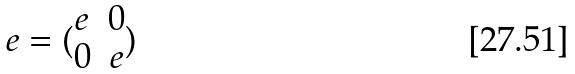<formula> <loc_0><loc_0><loc_500><loc_500>e = ( \begin{matrix} e & 0 \\ 0 & e \end{matrix} )</formula> 